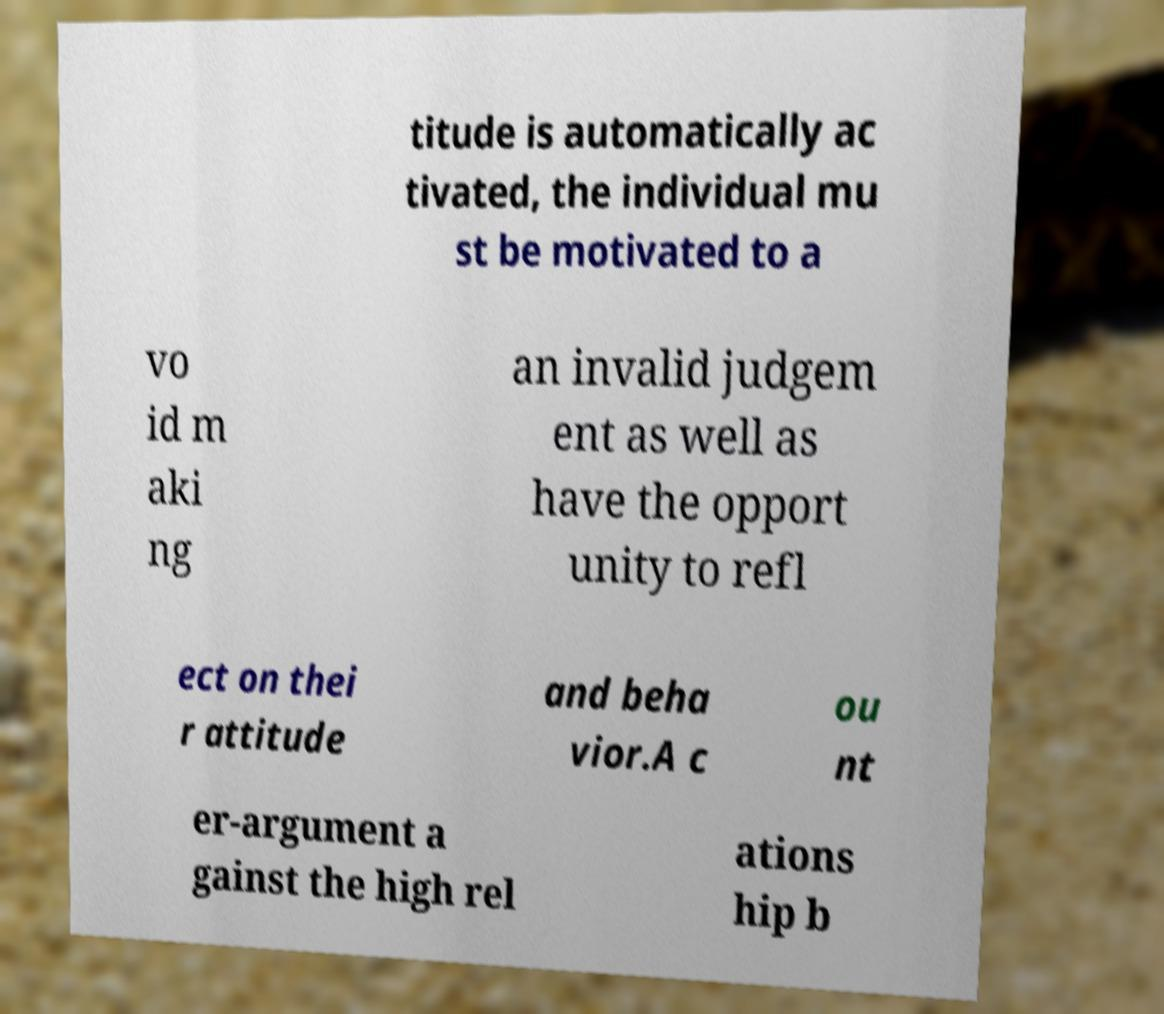What messages or text are displayed in this image? I need them in a readable, typed format. titude is automatically ac tivated, the individual mu st be motivated to a vo id m aki ng an invalid judgem ent as well as have the opport unity to refl ect on thei r attitude and beha vior.A c ou nt er-argument a gainst the high rel ations hip b 